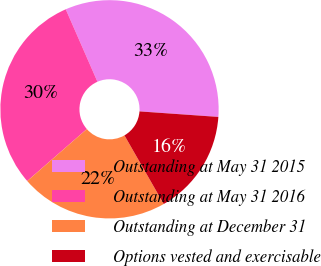Convert chart to OTSL. <chart><loc_0><loc_0><loc_500><loc_500><pie_chart><fcel>Outstanding at May 31 2015<fcel>Outstanding at May 31 2016<fcel>Outstanding at December 31<fcel>Options vested and exercisable<nl><fcel>32.68%<fcel>29.85%<fcel>21.86%<fcel>15.61%<nl></chart> 